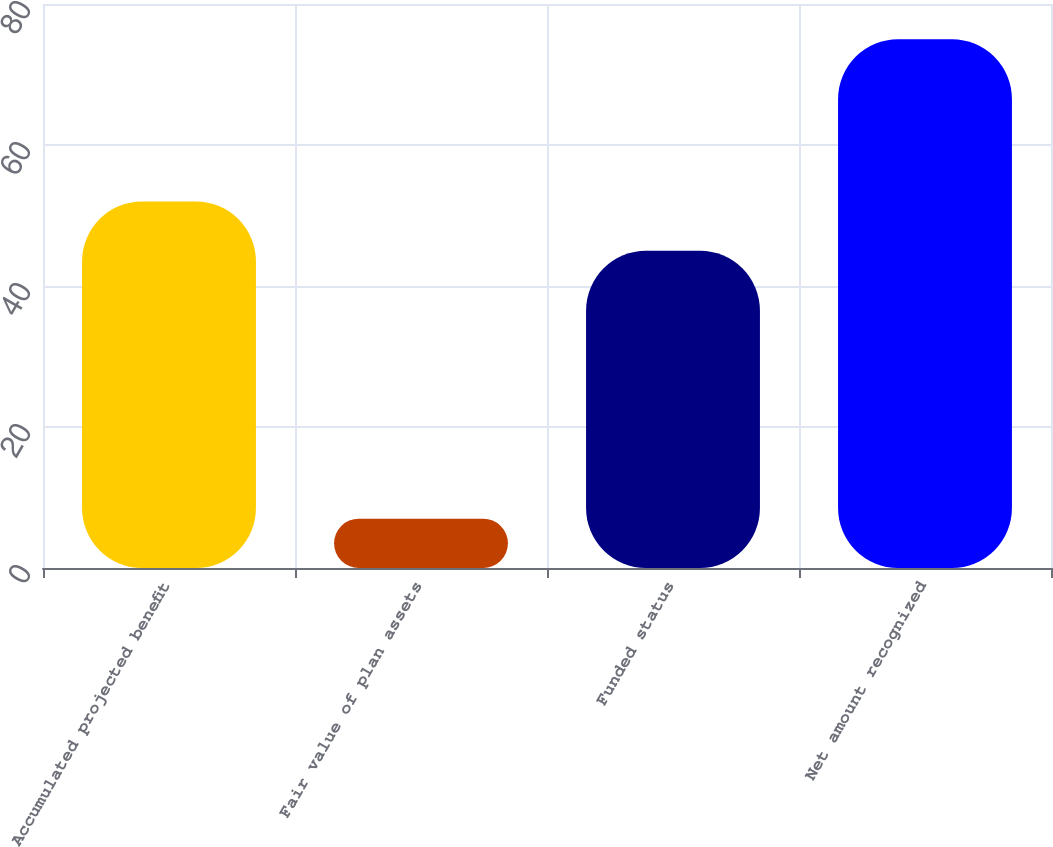Convert chart. <chart><loc_0><loc_0><loc_500><loc_500><bar_chart><fcel>Accumulated projected benefit<fcel>Fair value of plan assets<fcel>Funded status<fcel>Net amount recognized<nl><fcel>52<fcel>7<fcel>45<fcel>75<nl></chart> 